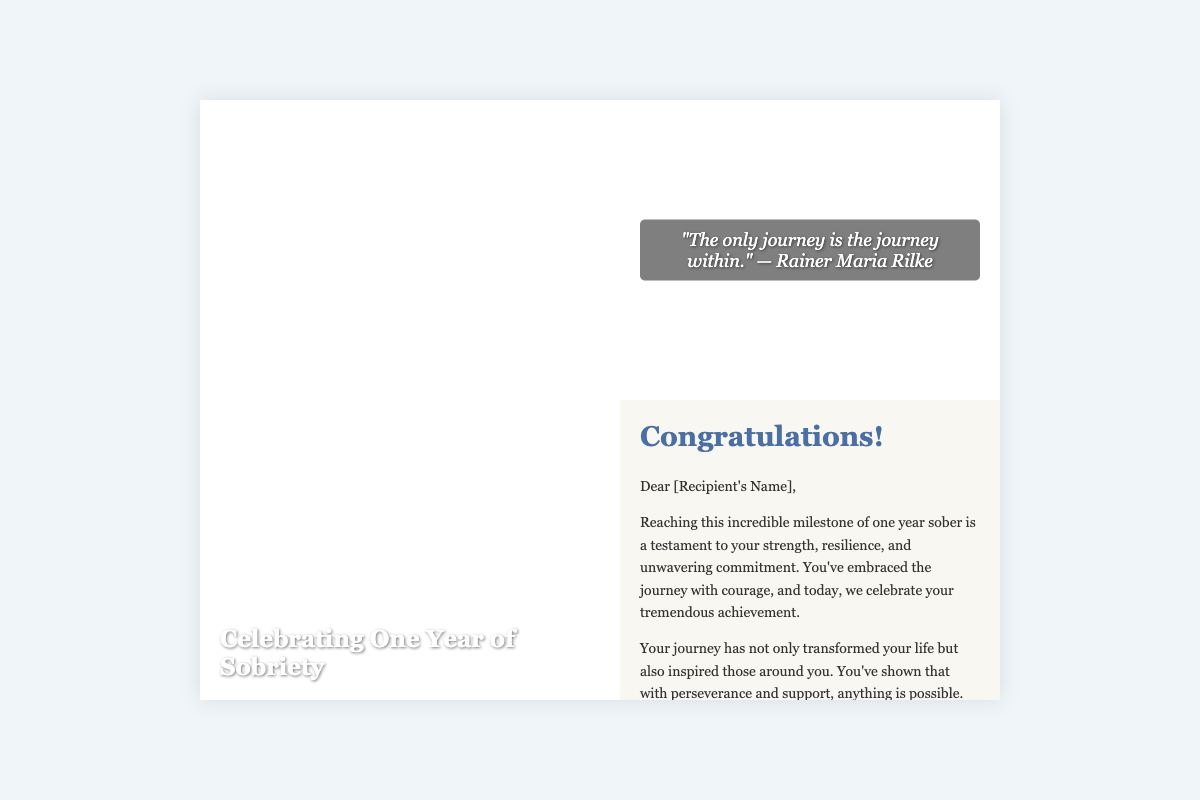What is the title of the greeting card? The title is prominently displayed on the front cover, stating the purpose of the card.
Answer: Celebrating One Year of Sobriety Who is the recipient of the message addressed to? The greeting card begins with a personal address to the individual who is being congratulated.
Answer: [Recipient's Name] What quote is featured on the inside left of the card? The card includes an inspirational quote that reflects on personal growth and introspection.
Answer: "The only journey is the journey within." — Rainer Maria Rilke Which important milestone is being celebrated? The card highlights a specific achievement related to sobriety that the recipient has accomplished.
Answer: One year sober What encouragement is provided in the message? The inside message includes a motivational statement meant to uplift the recipient.
Answer: "You are braver than you believe, stronger than you seem, and smarter than you think." — A.A. Milne What does the card suggest the recipient should remember? The message contains advice that emphasizes the significance of the recipient's journey and experience.
Answer: Each day is a new beginning Who is the sender of the message? The card concludes with a personal touch, allowing the sender to express their identity or group affiliation.
Answer: [Your Name/AA Group Name] 